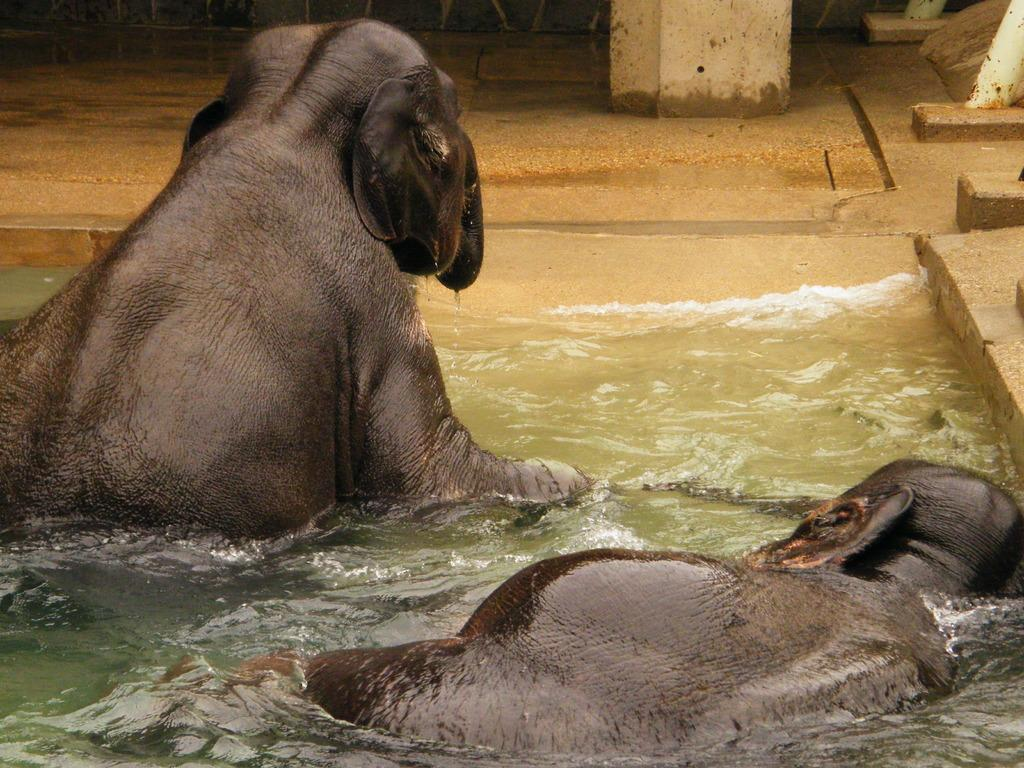What type of animals can be seen in the water in the image? There are two animals visible in the water in the image. What is located at the top of the image? There is a beam and a floor visible at the top of the image. What type of oatmeal is being served to the squirrel in the image? There is no squirrel or oatmeal present in the image. Who is the porter in the image? There is no porter present in the image. 